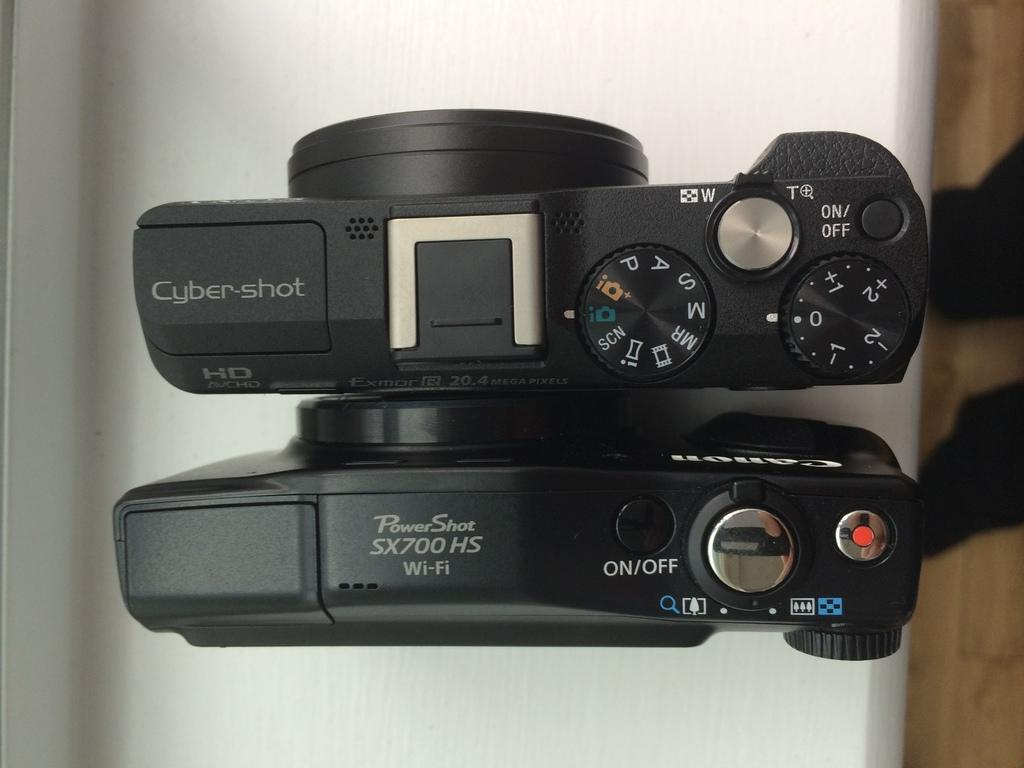Provide a one-sentence caption for the provided image. A Cyber-shot camera is next to a PowerShot camera on a white counter. 